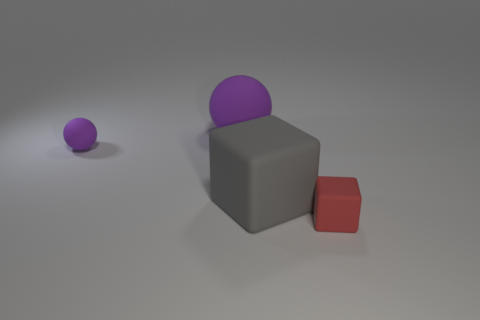Is there anything in the image that suggests its scale or the actual size of the objects? Without any familiar objects or reference points, it's difficult to determine the true scale of the objects in the image. They could be tiny models or large industrial objects. 